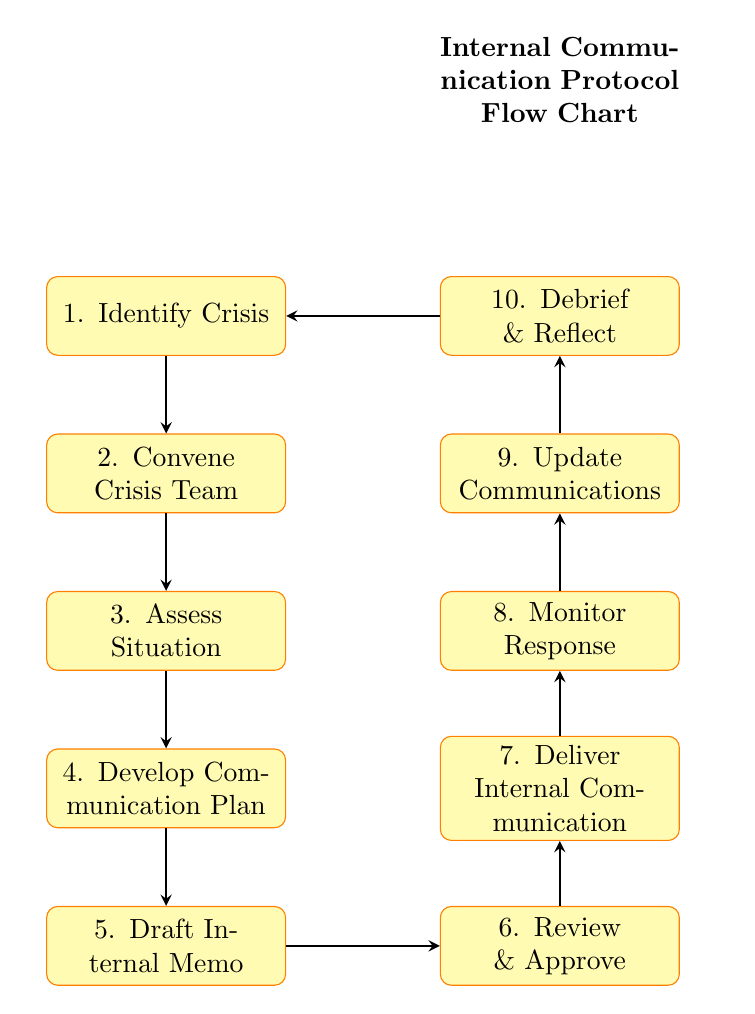What is the first step in the process? The first step in the process is labeled as "1. Identify Crisis," which is the top-most node in the flow chart.
Answer: Identify Crisis How many nodes are there in the flow chart? Counting all the unique process steps, there are 10 nodes in total present in the flow chart.
Answer: 10 What is the last step before debriefing? The last step before debriefing is "9. Update Communications," indicating that the update occurs just before the debriefing takes place.
Answer: Update Communications What step directly follows "Draft Internal Memo"? The step that directly follows "Draft Internal Memo" is "6. Review & Approve," which shows the sequence of actions after drafting the memo.
Answer: Review & Approve Which nodes are parallel in the process? In the diagram, "6. Review & Approve" is positioned parallel to the "7. Deliver Internal Communication" node, signifying that these steps are concurrent in the flow of the process.
Answer: Review & Approve, Deliver Internal Communication What is the main purpose of "Monitor Response"? The purpose of "Monitor Response" is to continuously track staff feedback and questions, ensuring management stays informed about employee sentiments during the crisis.
Answer: Continuously track staff feedback and questions Which step leads back to the start of the process? The step that leads back to the start of the process is "10. Debrief & Reflect," which has a directional arrow returning to "1. Identify Crisis."
Answer: Debrief & Reflect 